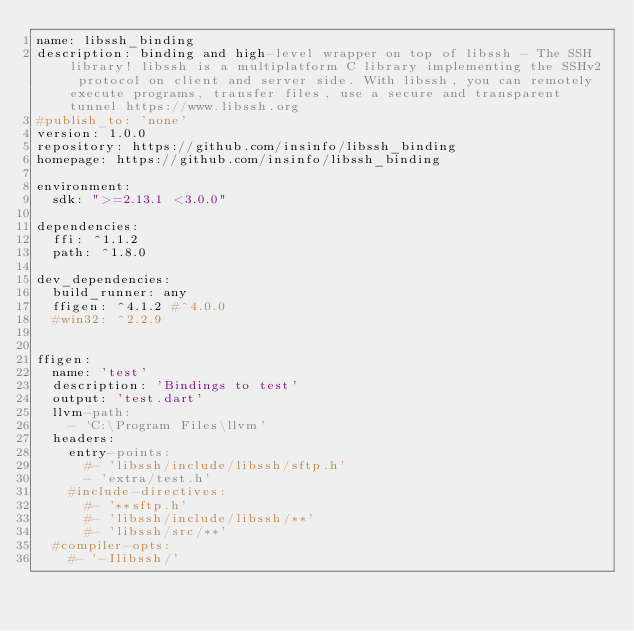<code> <loc_0><loc_0><loc_500><loc_500><_YAML_>name: libssh_binding
description: binding and high-level wrapper on top of libssh - The SSH library! libssh is a multiplatform C library implementing the SSHv2 protocol on client and server side. With libssh, you can remotely execute programs, transfer files, use a secure and transparent tunnel https://www.libssh.org
#publish_to: 'none' 
version: 1.0.0
repository: https://github.com/insinfo/libssh_binding
homepage: https://github.com/insinfo/libssh_binding

environment:
  sdk: ">=2.13.1 <3.0.0"

dependencies:
  ffi: ^1.1.2
  path: ^1.8.0

dev_dependencies: 
  build_runner: any
  ffigen: ^4.1.2 #^4.0.0
  #win32: ^2.2.9


ffigen:
  name: 'test'
  description: 'Bindings to test'
  output: 'test.dart'
  llvm-path:     
    - 'C:\Program Files\llvm'      
  headers:
    entry-points:
      #- 'libssh/include/libssh/sftp.h'     
      - 'extra/test.h' 
    #include-directives:
      #- '**sftp.h'
      #- 'libssh/include/libssh/**'
      #- 'libssh/src/**'
  #compiler-opts:
    #- '-Ilibssh/'</code> 